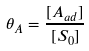<formula> <loc_0><loc_0><loc_500><loc_500>\theta _ { A } = \frac { [ A _ { a d } ] } { [ S _ { 0 } ] }</formula> 